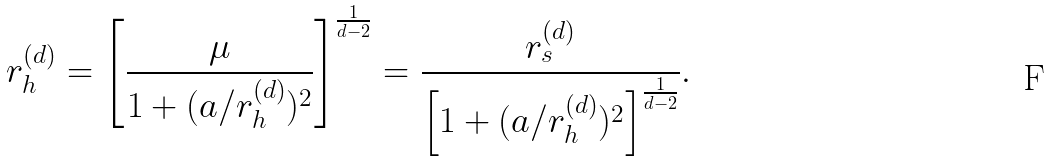<formula> <loc_0><loc_0><loc_500><loc_500>r ^ { ( d ) } _ { h } = \left [ \frac { \mu } { 1 + ( a / r ^ { ( d ) } _ { h } ) ^ { 2 } } \right ] ^ { \frac { 1 } { d - 2 } } = \frac { r ^ { ( d ) } _ { s } } { \left [ 1 + ( a / r ^ { ( d ) } _ { h } ) ^ { 2 } \right ] ^ { \frac { 1 } { d - 2 } } } .</formula> 